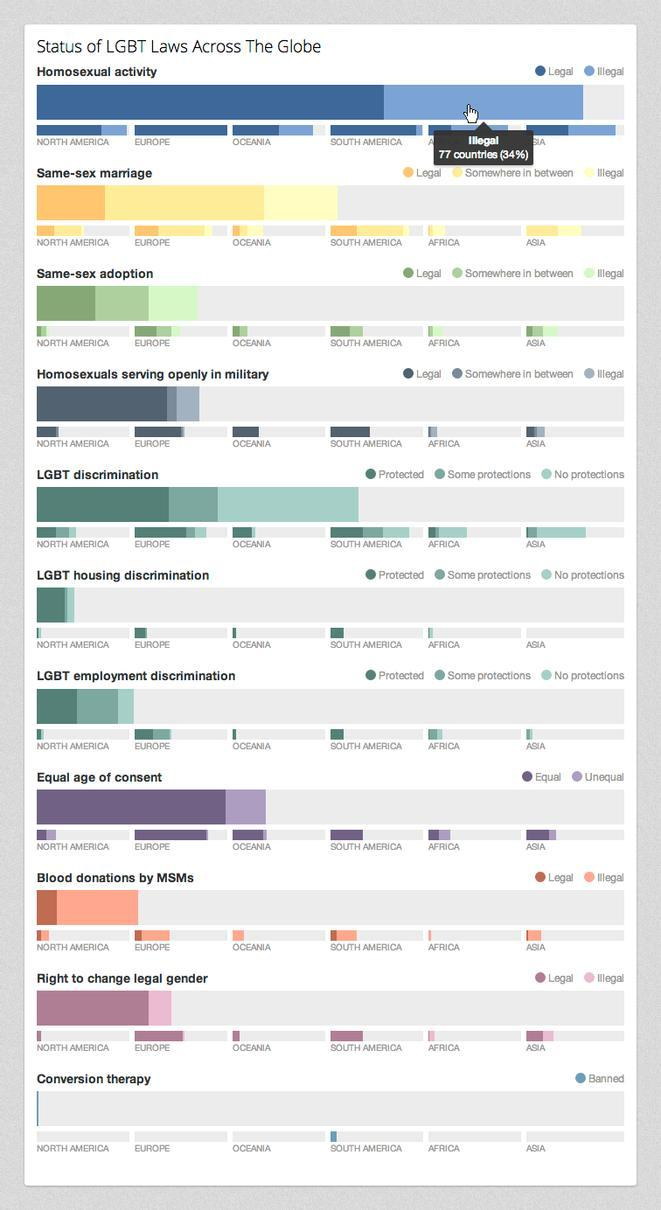Countries in which continent have banned conversion therapy?
Answer the question with a short phrase. South America Which continent shows highest percentage of protection against LGBT discrimination? Europe Which continent show highest rate of homosexuals serving in military? Europe 